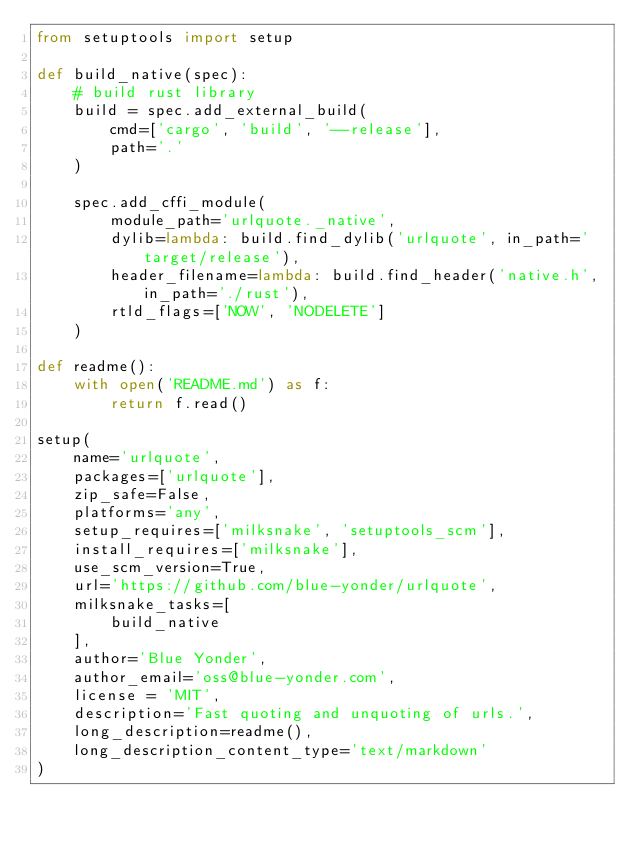<code> <loc_0><loc_0><loc_500><loc_500><_Python_>from setuptools import setup

def build_native(spec):
    # build rust library
    build = spec.add_external_build(
        cmd=['cargo', 'build', '--release'],
        path='.'
    )

    spec.add_cffi_module(
        module_path='urlquote._native',
        dylib=lambda: build.find_dylib('urlquote', in_path='target/release'),
        header_filename=lambda: build.find_header('native.h', in_path='./rust'),
        rtld_flags=['NOW', 'NODELETE']
    )

def readme():
    with open('README.md') as f:
        return f.read()

setup(
    name='urlquote',
    packages=['urlquote'],
    zip_safe=False,
    platforms='any',
    setup_requires=['milksnake', 'setuptools_scm'],
    install_requires=['milksnake'],
    use_scm_version=True,
    url='https://github.com/blue-yonder/urlquote',
    milksnake_tasks=[
        build_native
    ],
    author='Blue Yonder',
    author_email='oss@blue-yonder.com',
    license = 'MIT',
    description='Fast quoting and unquoting of urls.',
    long_description=readme(),
    long_description_content_type='text/markdown'
)</code> 